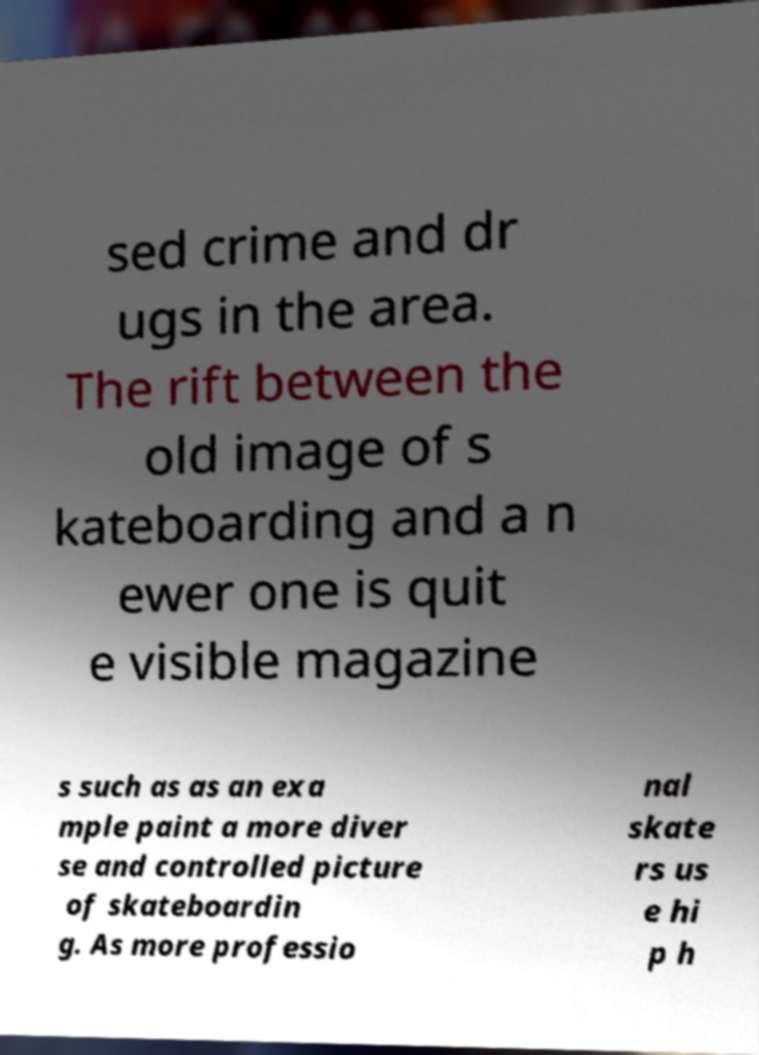Please read and relay the text visible in this image. What does it say? sed crime and dr ugs in the area. The rift between the old image of s kateboarding and a n ewer one is quit e visible magazine s such as as an exa mple paint a more diver se and controlled picture of skateboardin g. As more professio nal skate rs us e hi p h 